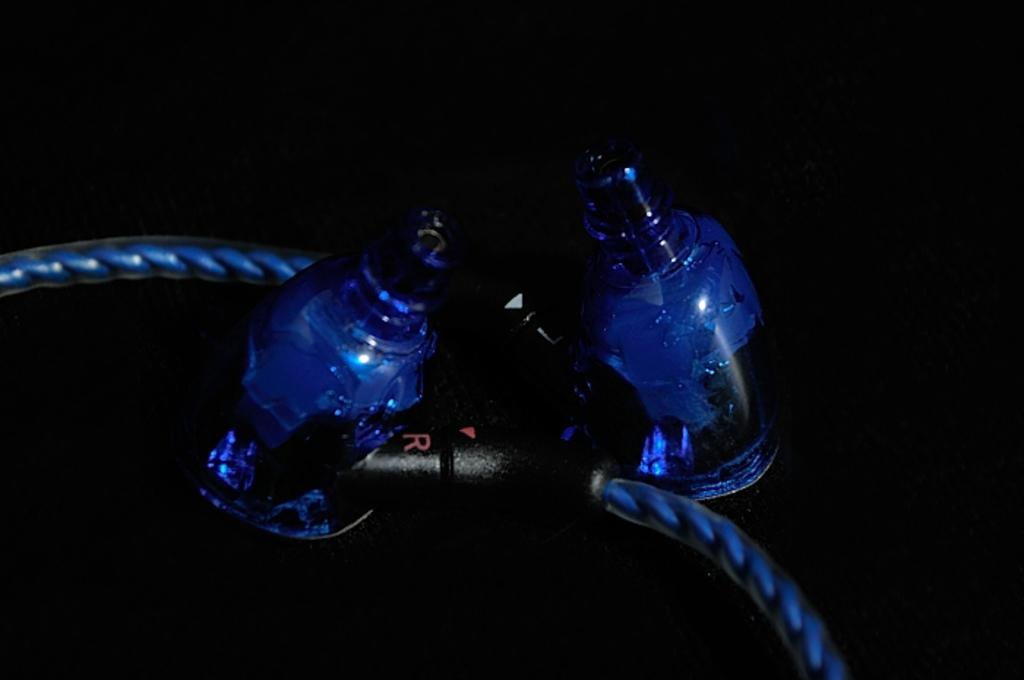<image>
Render a clear and concise summary of the photo. A red R is seen on a part of a cord against two blue objects. 